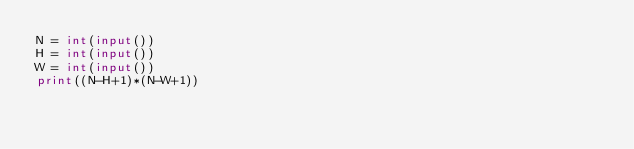Convert code to text. <code><loc_0><loc_0><loc_500><loc_500><_Python_>N = int(input())
H = int(input())
W = int(input())
print((N-H+1)*(N-W+1))</code> 